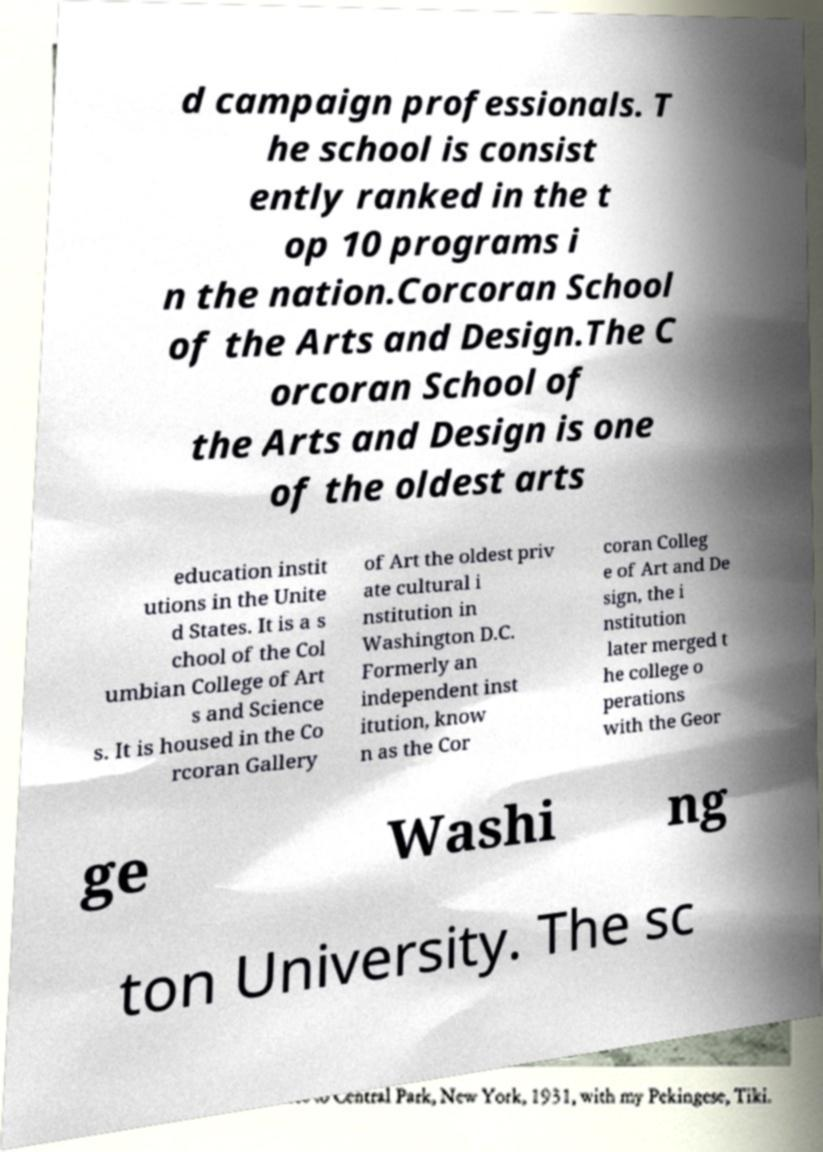Can you read and provide the text displayed in the image?This photo seems to have some interesting text. Can you extract and type it out for me? d campaign professionals. T he school is consist ently ranked in the t op 10 programs i n the nation.Corcoran School of the Arts and Design.The C orcoran School of the Arts and Design is one of the oldest arts education instit utions in the Unite d States. It is a s chool of the Col umbian College of Art s and Science s. It is housed in the Co rcoran Gallery of Art the oldest priv ate cultural i nstitution in Washington D.C. Formerly an independent inst itution, know n as the Cor coran Colleg e of Art and De sign, the i nstitution later merged t he college o perations with the Geor ge Washi ng ton University. The sc 